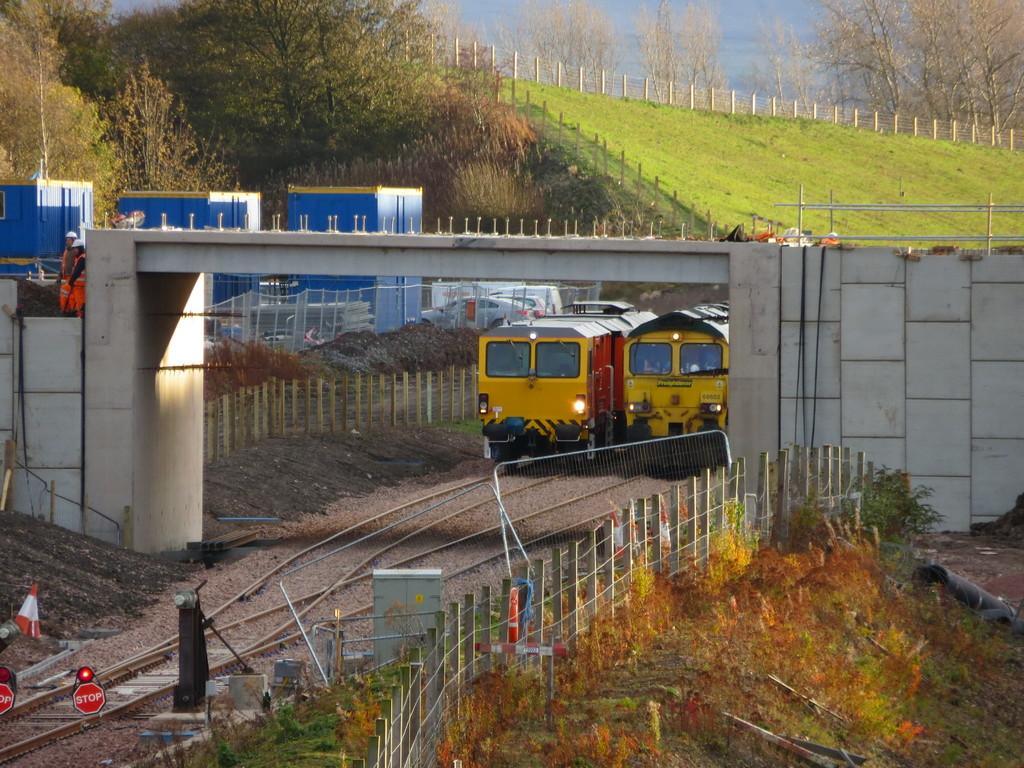Could you give a brief overview of what you see in this image? In this image, we can see trains, train tracks, bridge, containers, vehicles, fences, plants, few people and objects. Background we can see trees, grass and fences. 